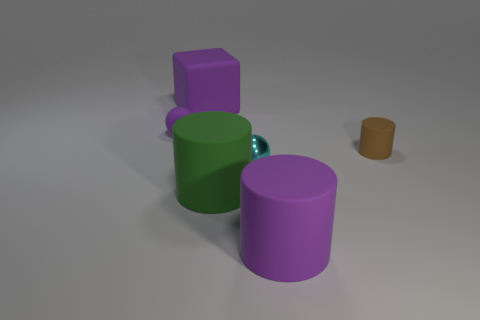Subtract all purple cylinders. How many cylinders are left? 2 Subtract all purple matte cylinders. How many cylinders are left? 2 Add 3 large cylinders. How many objects exist? 9 Subtract all spheres. How many objects are left? 4 Subtract all blue balls. How many brown cylinders are left? 1 Subtract all cyan metallic cubes. Subtract all green things. How many objects are left? 5 Add 1 cubes. How many cubes are left? 2 Add 1 large matte cylinders. How many large matte cylinders exist? 3 Subtract 0 blue spheres. How many objects are left? 6 Subtract 1 cylinders. How many cylinders are left? 2 